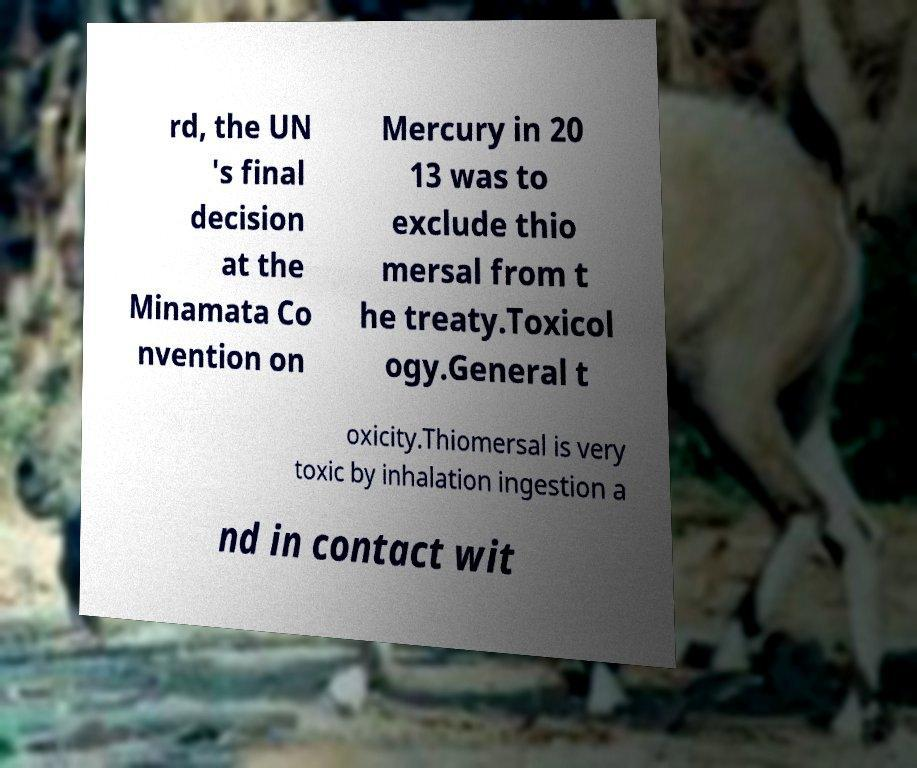I need the written content from this picture converted into text. Can you do that? rd, the UN 's final decision at the Minamata Co nvention on Mercury in 20 13 was to exclude thio mersal from t he treaty.Toxicol ogy.General t oxicity.Thiomersal is very toxic by inhalation ingestion a nd in contact wit 